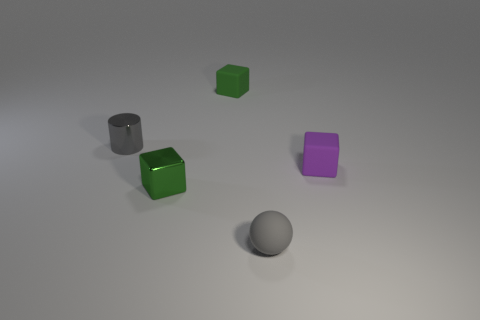Subtract all small metal cubes. How many cubes are left? 2 Add 1 purple matte cubes. How many objects exist? 6 Subtract all green cubes. How many cubes are left? 1 Subtract all cylinders. How many objects are left? 4 Subtract 1 spheres. How many spheres are left? 0 Subtract all green cubes. Subtract all brown spheres. How many cubes are left? 1 Subtract all green cylinders. How many green blocks are left? 2 Subtract all big red metal blocks. Subtract all small gray rubber things. How many objects are left? 4 Add 2 shiny cylinders. How many shiny cylinders are left? 3 Add 3 matte objects. How many matte objects exist? 6 